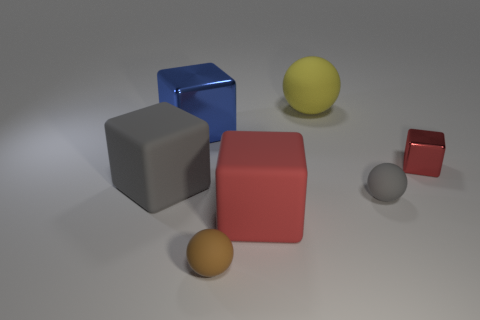What shapes are present in the image, and how do they relate to each other in terms of size? The image includes a variety of shapes: there are cubes, balls, and what appears to be a cuboid. The largest shape is the red cuboid, followed by the blue cube, the grey cube, and then the smaller objects, including the small red cube and the balls in descending size order. 